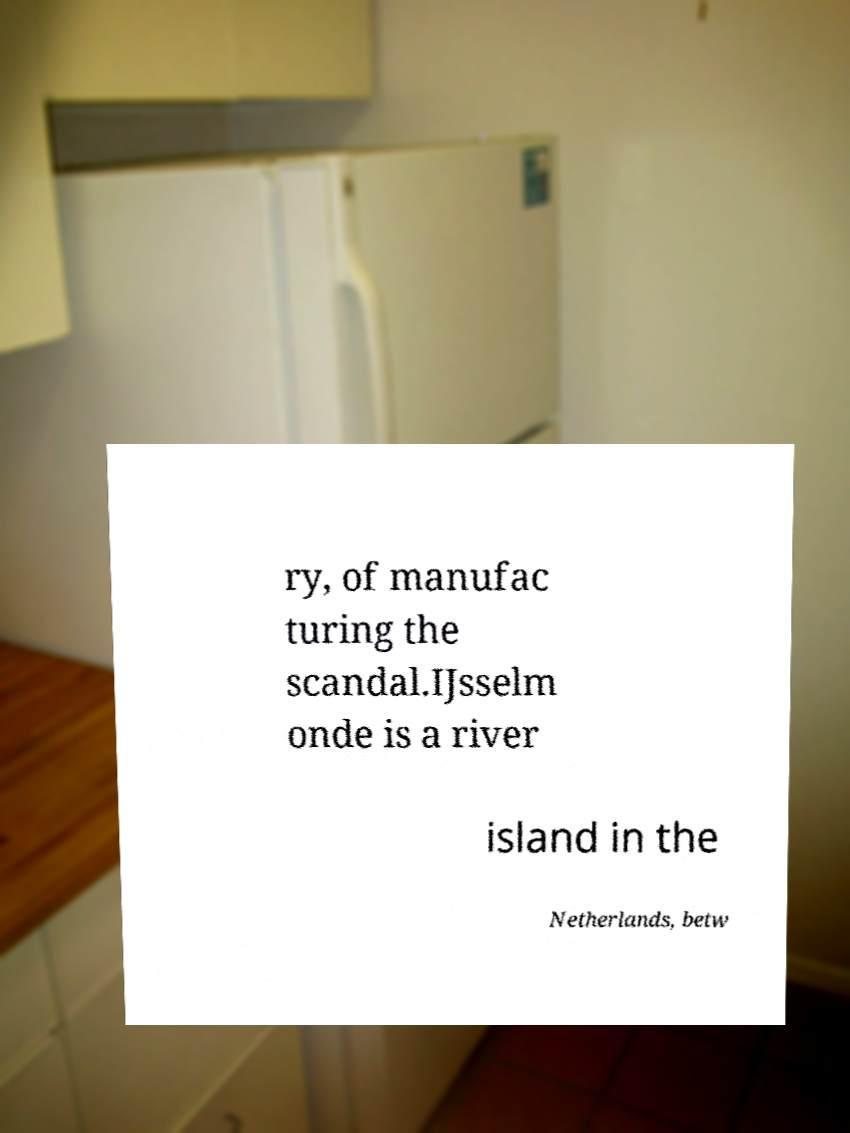Could you extract and type out the text from this image? ry, of manufac turing the scandal.IJsselm onde is a river island in the Netherlands, betw 